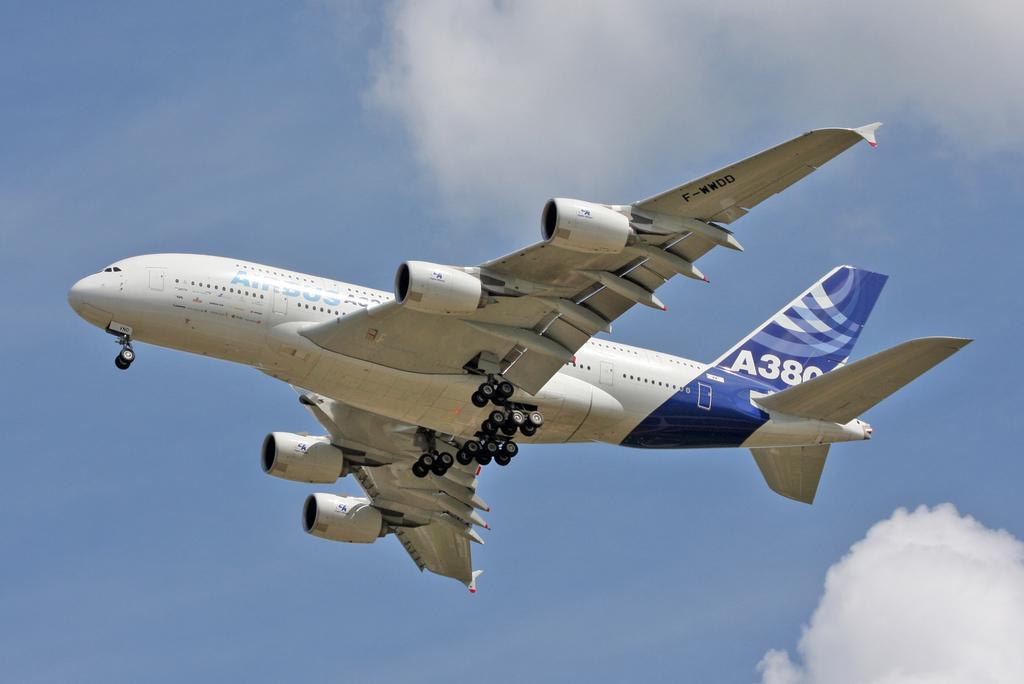<image>
Render a clear and concise summary of the photo. Airbus A380 white and blue airplane in the sky 